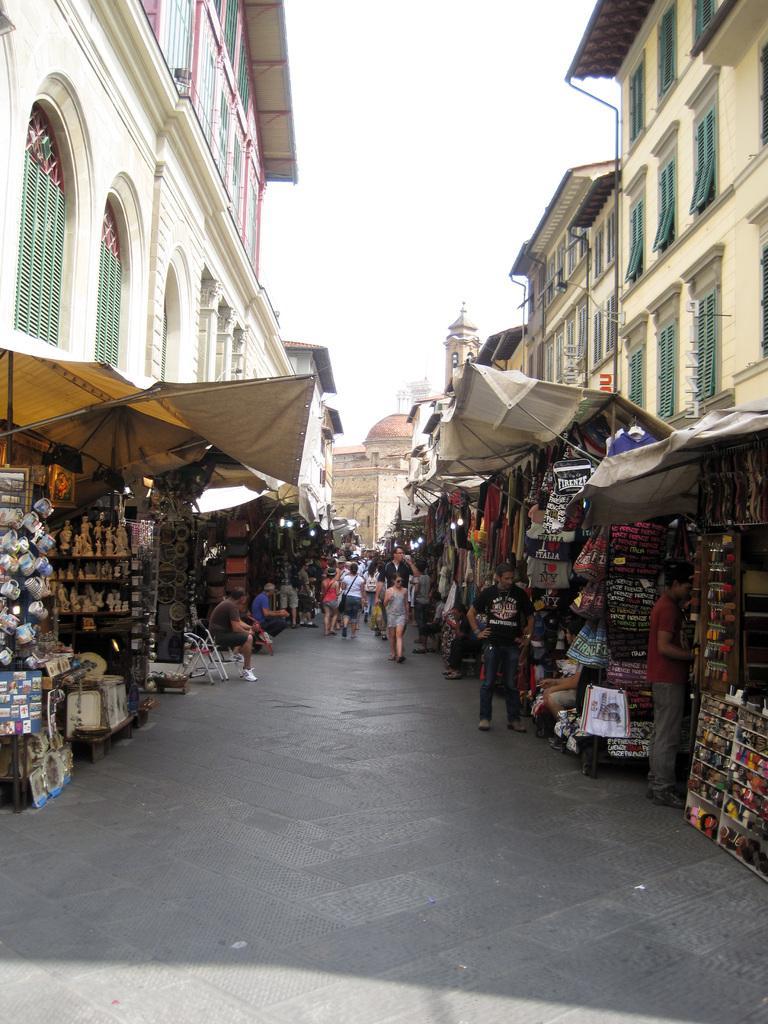Can you describe this image briefly? In this image, we can see so many buildings, stalls, some objects, cups and people. In the middle of the image, there is a walkway. Few people are walking through the walkway. Background there is a sky. Here we can see wall, windows and pipes. 